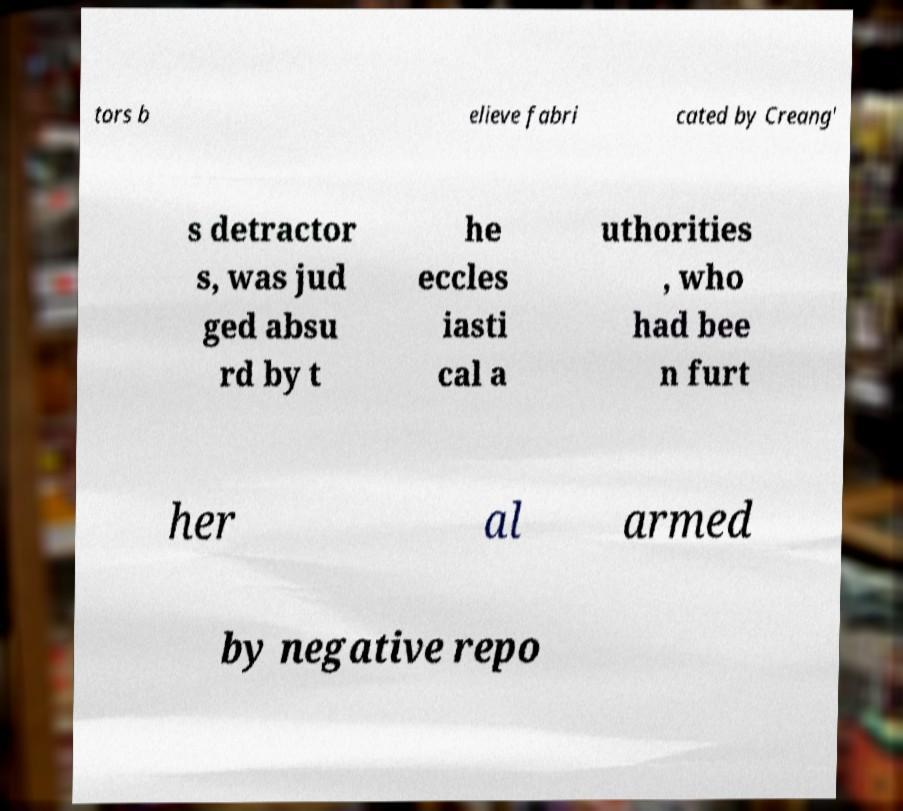I need the written content from this picture converted into text. Can you do that? tors b elieve fabri cated by Creang' s detractor s, was jud ged absu rd by t he eccles iasti cal a uthorities , who had bee n furt her al armed by negative repo 